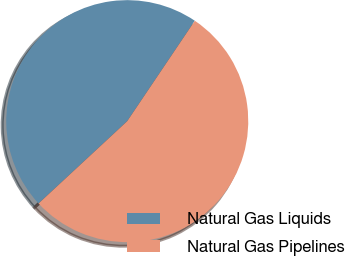<chart> <loc_0><loc_0><loc_500><loc_500><pie_chart><fcel>Natural Gas Liquids<fcel>Natural Gas Pipelines<nl><fcel>46.34%<fcel>53.66%<nl></chart> 